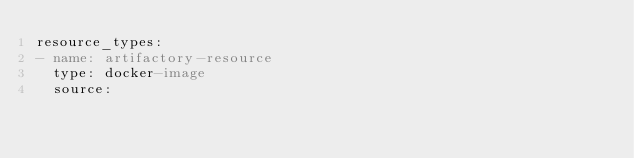<code> <loc_0><loc_0><loc_500><loc_500><_YAML_>resource_types:
- name: artifactory-resource
  type: docker-image
  source:</code> 